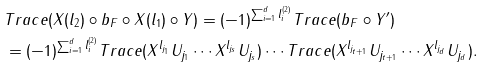<formula> <loc_0><loc_0><loc_500><loc_500>& T r a c e ( X ( l _ { 2 } ) \circ b _ { F } \circ X ( l _ { 1 } ) \circ Y ) = ( - 1 ) ^ { \sum _ { i = 1 } ^ { d } l _ { i } ^ { ( 2 ) } } T r a c e ( b _ { F } \circ Y ^ { \prime } ) \\ & = ( - 1 ) ^ { \sum _ { i = 1 } ^ { d } l _ { i } ^ { ( 2 ) } } T r a c e ( X ^ { l _ { j _ { 1 } } } U _ { j _ { 1 } } \cdots X ^ { l _ { j _ { s } } } U _ { j _ { s } } ) \cdots T r a c e ( X ^ { l _ { j _ { t + 1 } } } U _ { j _ { t + 1 } } \cdots X ^ { l _ { j _ { d } } } U _ { j _ { d } } ) .</formula> 